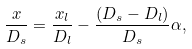Convert formula to latex. <formula><loc_0><loc_0><loc_500><loc_500>\frac { x } { D _ { s } } = \frac { x _ { l } } { D _ { l } } - \frac { ( D _ { s } - D _ { l } ) } { D _ { s } } \alpha ,</formula> 